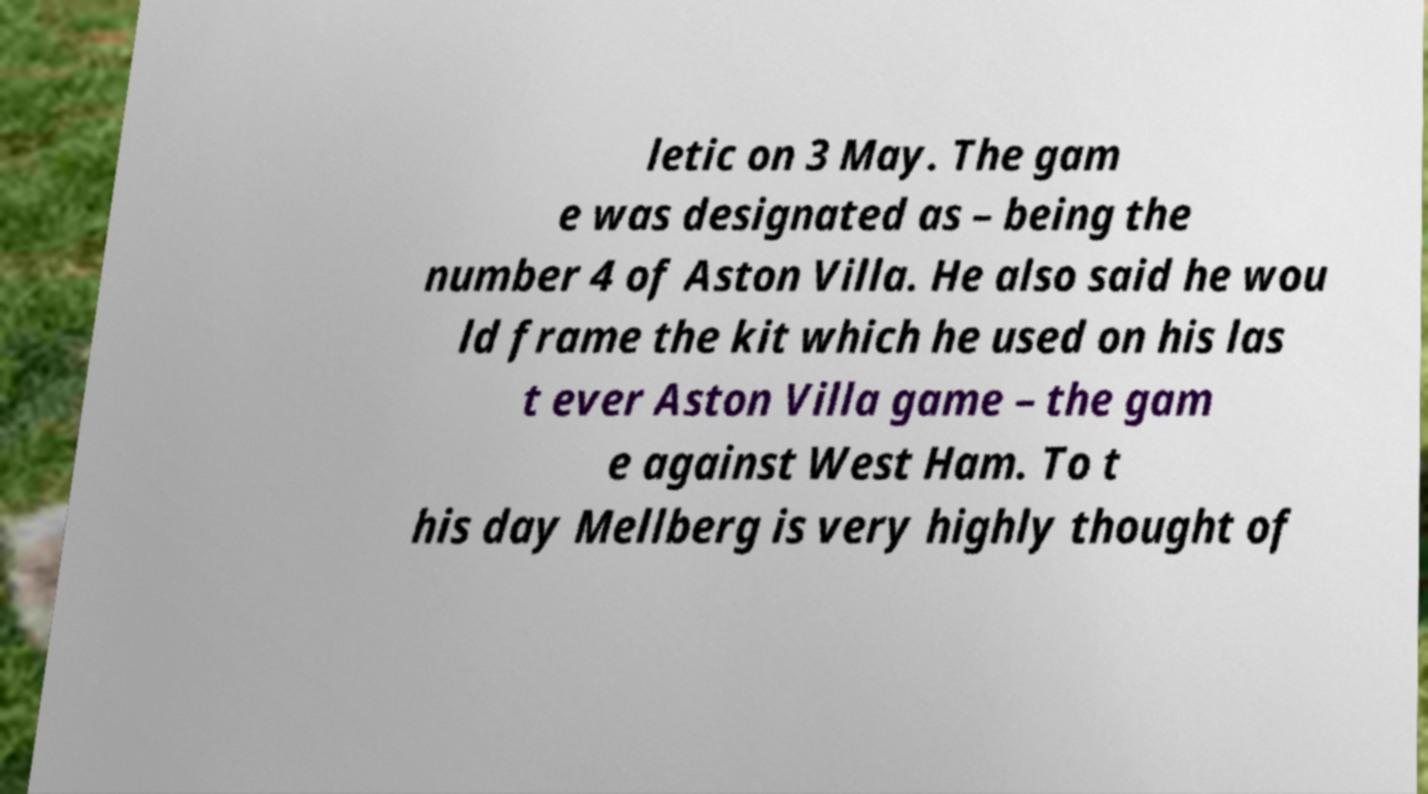What messages or text are displayed in this image? I need them in a readable, typed format. letic on 3 May. The gam e was designated as – being the number 4 of Aston Villa. He also said he wou ld frame the kit which he used on his las t ever Aston Villa game – the gam e against West Ham. To t his day Mellberg is very highly thought of 